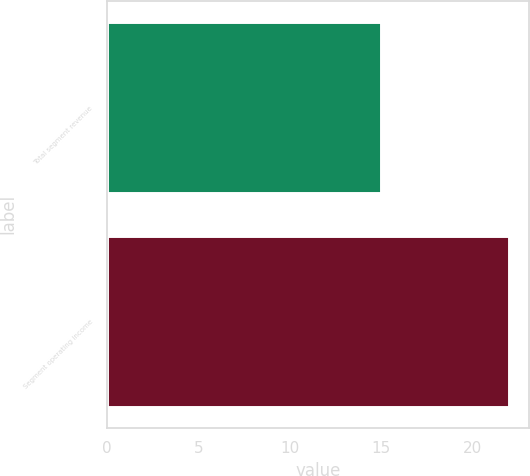Convert chart. <chart><loc_0><loc_0><loc_500><loc_500><bar_chart><fcel>Total segment revenue<fcel>Segment operating income<nl><fcel>15<fcel>22<nl></chart> 